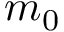Convert formula to latex. <formula><loc_0><loc_0><loc_500><loc_500>m _ { 0 }</formula> 